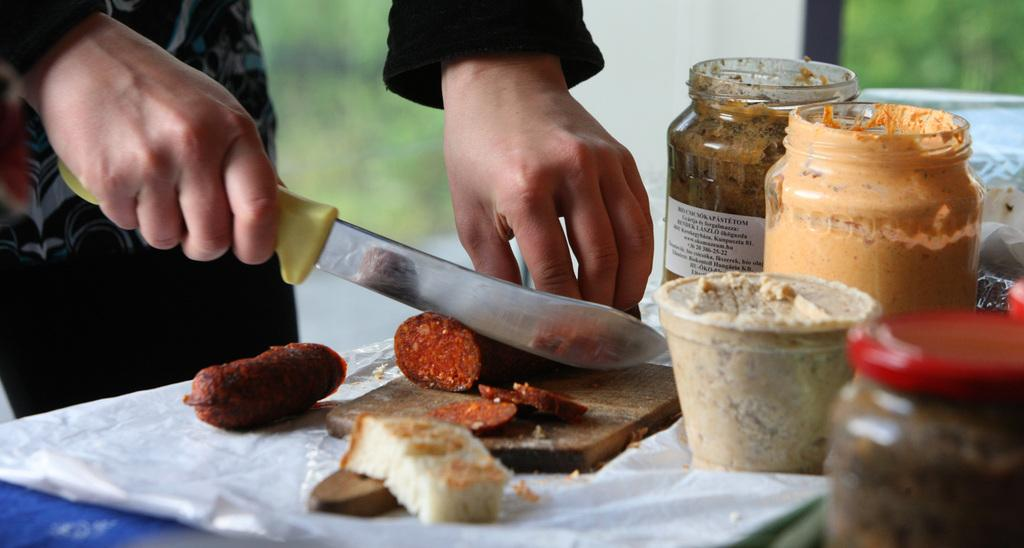What is the person in the image doing? The person is cutting food. What tool is the person using to cut the food? The person is using a knife. What surface is the person using to cut the food on? There is a chopping board in the image. What can be seen on the right side of the image? There are pickle bottles on the right side of the image. What verse is the person reciting while cutting the food in the image? There is no indication in the image that the person is reciting a verse while cutting the food. 